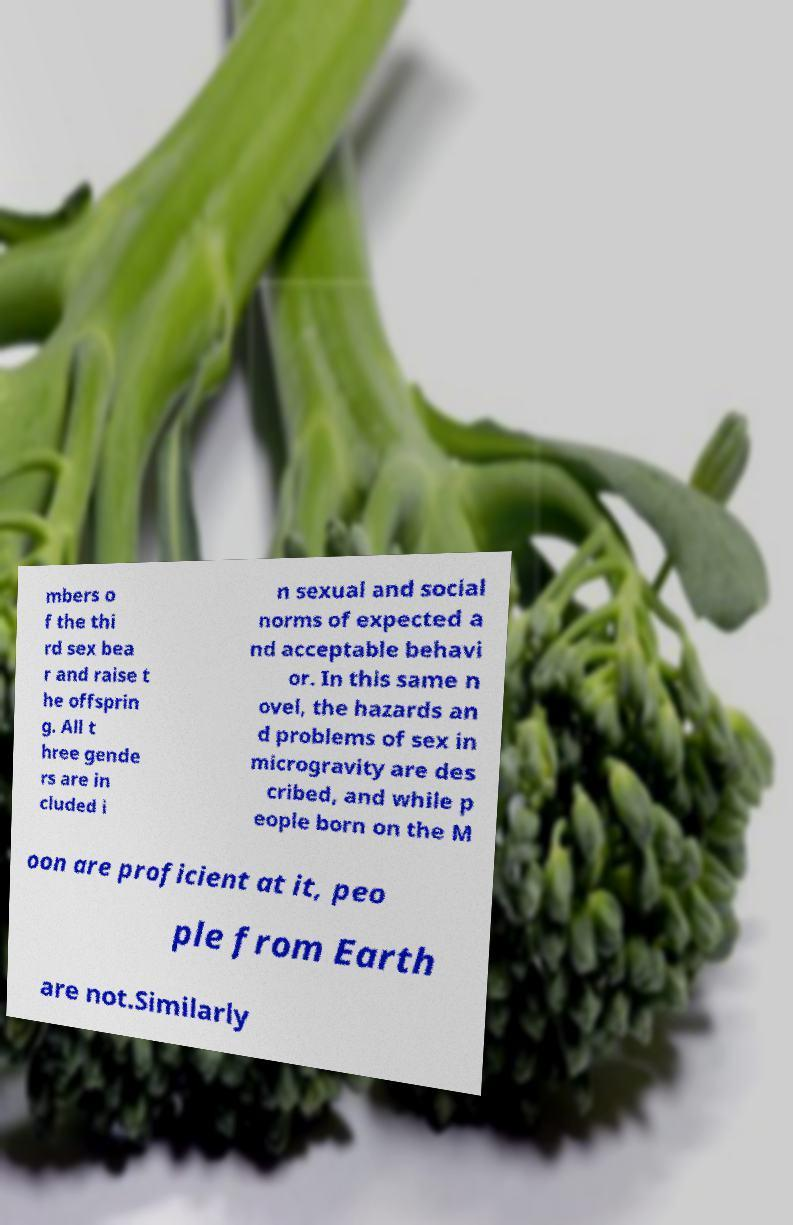There's text embedded in this image that I need extracted. Can you transcribe it verbatim? mbers o f the thi rd sex bea r and raise t he offsprin g. All t hree gende rs are in cluded i n sexual and social norms of expected a nd acceptable behavi or. In this same n ovel, the hazards an d problems of sex in microgravity are des cribed, and while p eople born on the M oon are proficient at it, peo ple from Earth are not.Similarly 